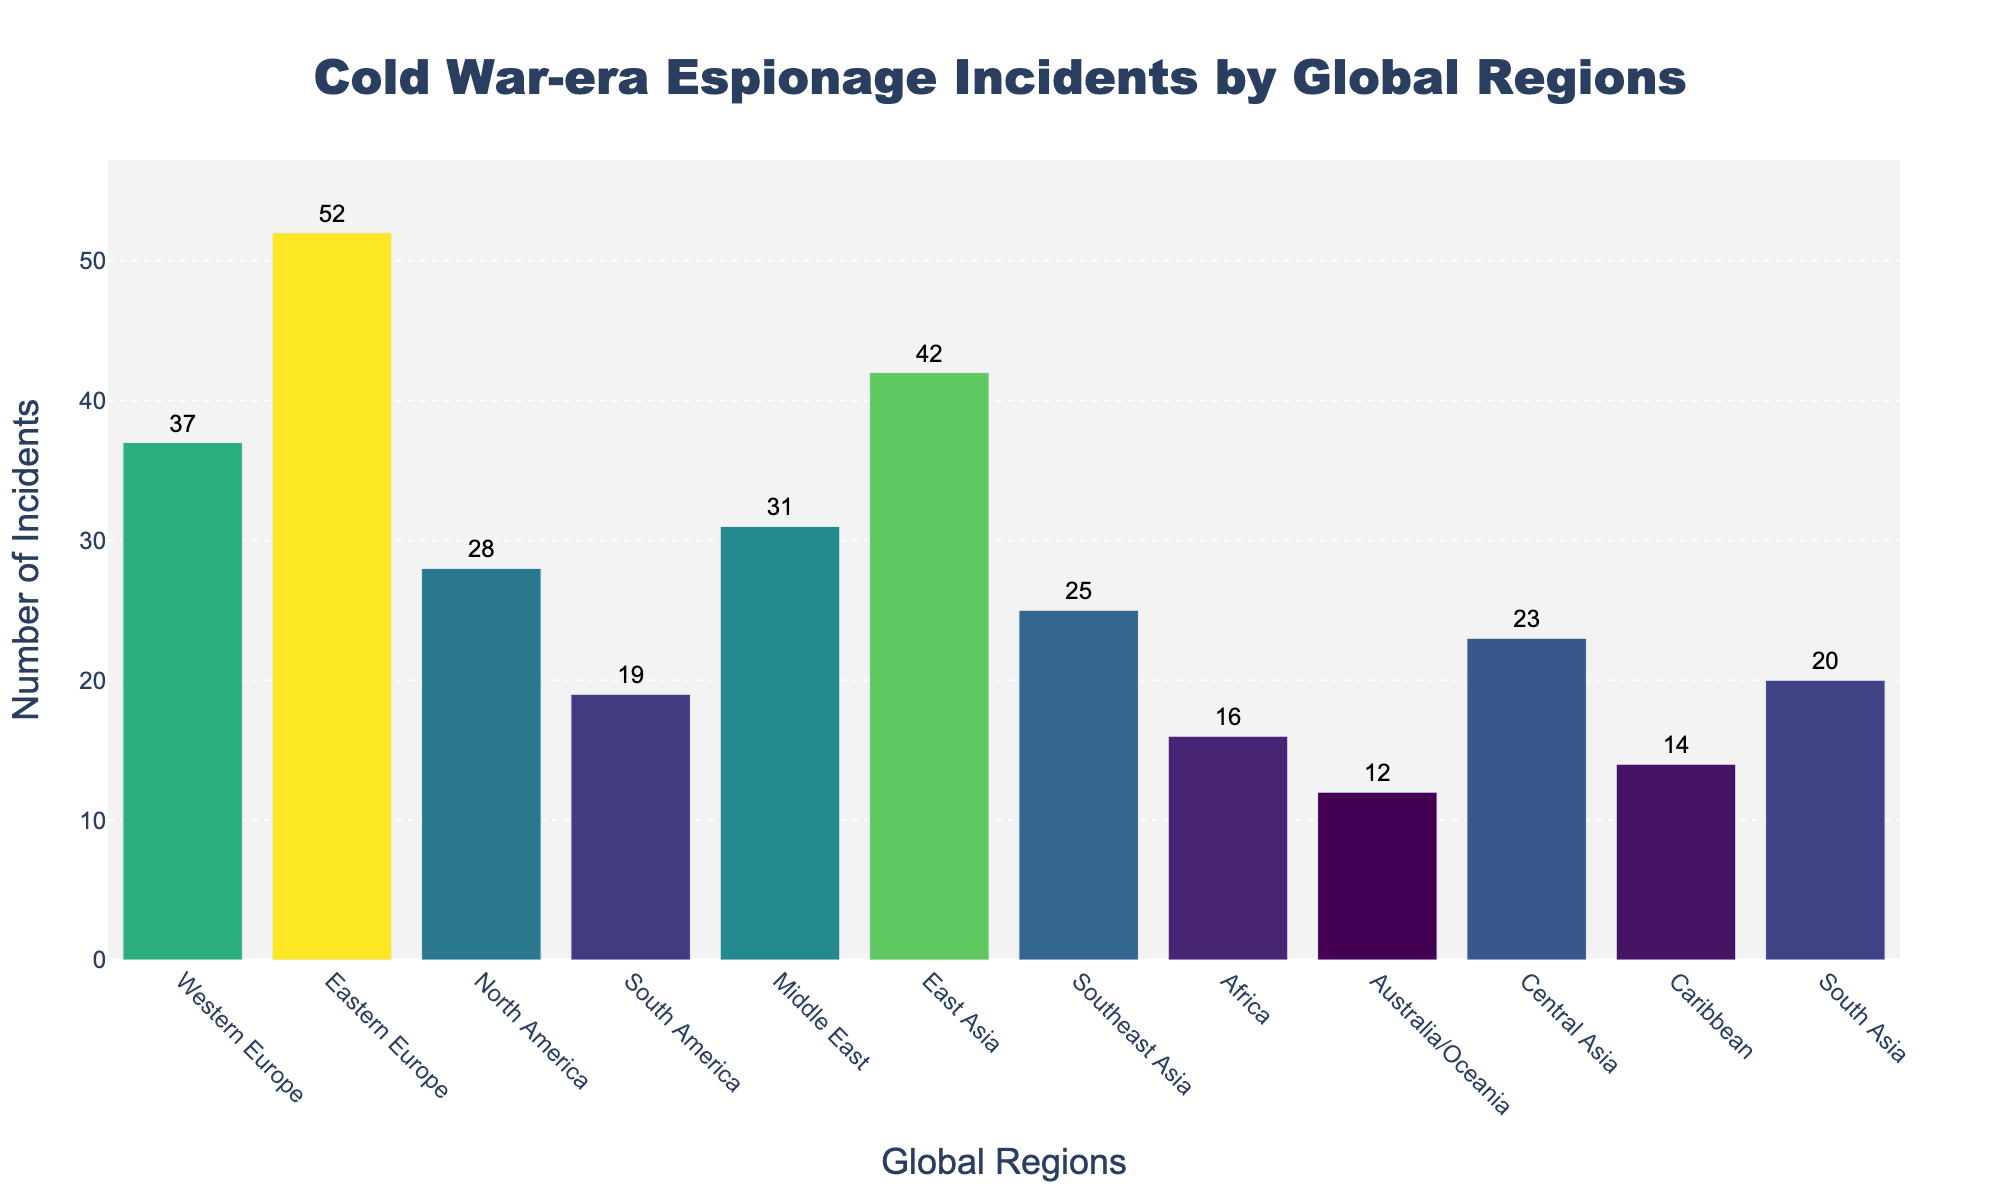Which region has the highest number of Cold War-era espionage incidents? The highest bar in the plot represents Eastern Europe at position 2 on the x-axis with 52 incidents.
Answer: Eastern Europe Which region has the fewest espionage incidents during the Cold War? The shortest bar in the chart corresponds to Australia/Oceania at position 9 on the x-axis with 12 incidents.
Answer: Australia/Oceania What is the total number of espionage incidents across all regions? Add the incidents from all regions: 37 + 52 + 28 + 19 + 31 + 42 + 25 + 16 + 12 + 23 + 14 + 20 = 319
Answer: 319 Which regions have more than 30 incidents? Identify the bars with numbers greater than 30: Western Europe (37), Eastern Europe (52), Middle East (31), East Asia (42)
Answer: Western Europe, Eastern Europe, Middle East, East Asia How many regions had between 15 and 25 incidents? Count the bars with numbers between 15 and 25: Southeast Asia (25), Central Asia (23), Caribbean (14), South Asia (20), Africa (16)
Answer: 5 Which region has slightly fewer espionage incidents than North America? North America has 28 incidents; the region with slightly fewer incidents is Southeast Asia with 25.
Answer: Southeast Asia What is the average number of Cold War-era espionage incidents per region? Total number of incidents is 319 and there are 12 regions, so the average is 319 / 12 ≈ 26.58
Answer: 26.58 Compare espionage incidents between North America and Western Europe. Which one had more incidents and by how much? North America has 28 incidents, and Western Europe has 37 incidents. The difference is 37 - 28 = 9
Answer: Western Europe, 9 What is the difference in espionage incidents between the Middle East and South America? Middle East has 31 incidents and South America has 19. The difference is 31 - 19 = 12
Answer: 12 Which regions are represented at the ends of the x-axis? The first position on the x-axis is Western Europe, and the last position is South Asia.
Answer: Western Europe, South Asia 